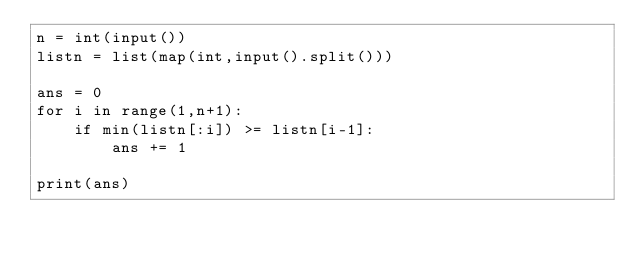Convert code to text. <code><loc_0><loc_0><loc_500><loc_500><_Python_>n = int(input())
listn = list(map(int,input().split()))

ans = 0
for i in range(1,n+1):
    if min(listn[:i]) >= listn[i-1]:
        ans += 1

print(ans)
    

</code> 